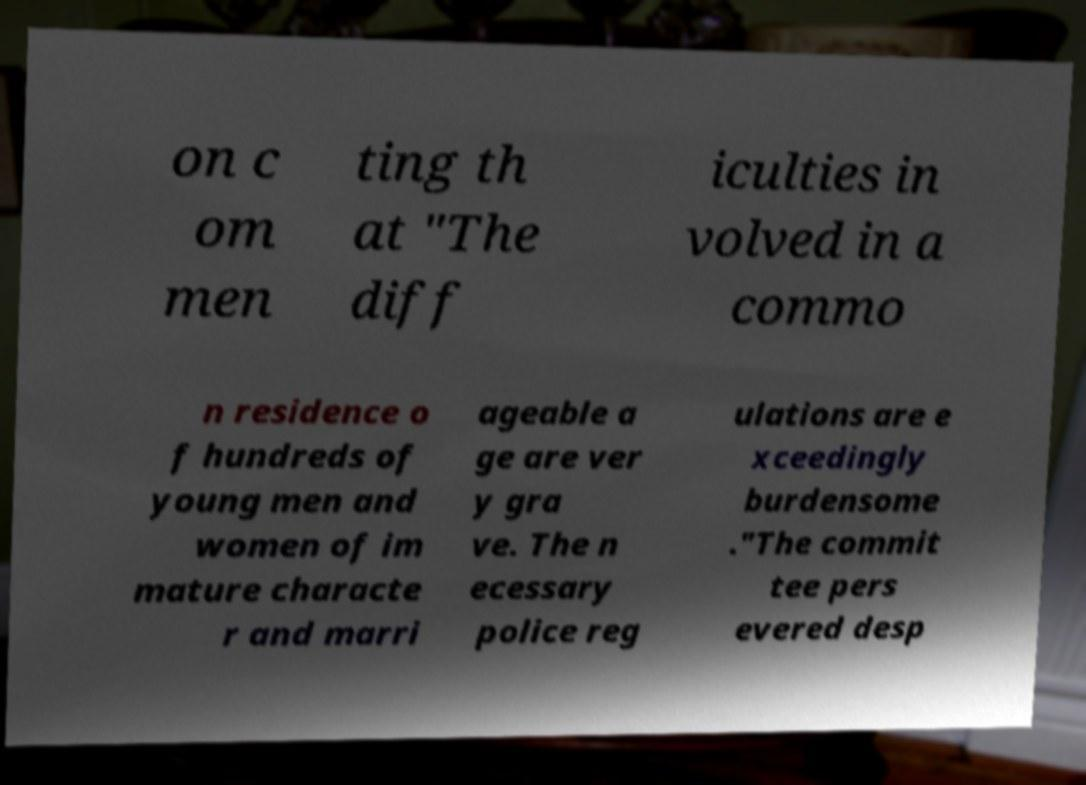For documentation purposes, I need the text within this image transcribed. Could you provide that? on c om men ting th at "The diff iculties in volved in a commo n residence o f hundreds of young men and women of im mature characte r and marri ageable a ge are ver y gra ve. The n ecessary police reg ulations are e xceedingly burdensome ."The commit tee pers evered desp 